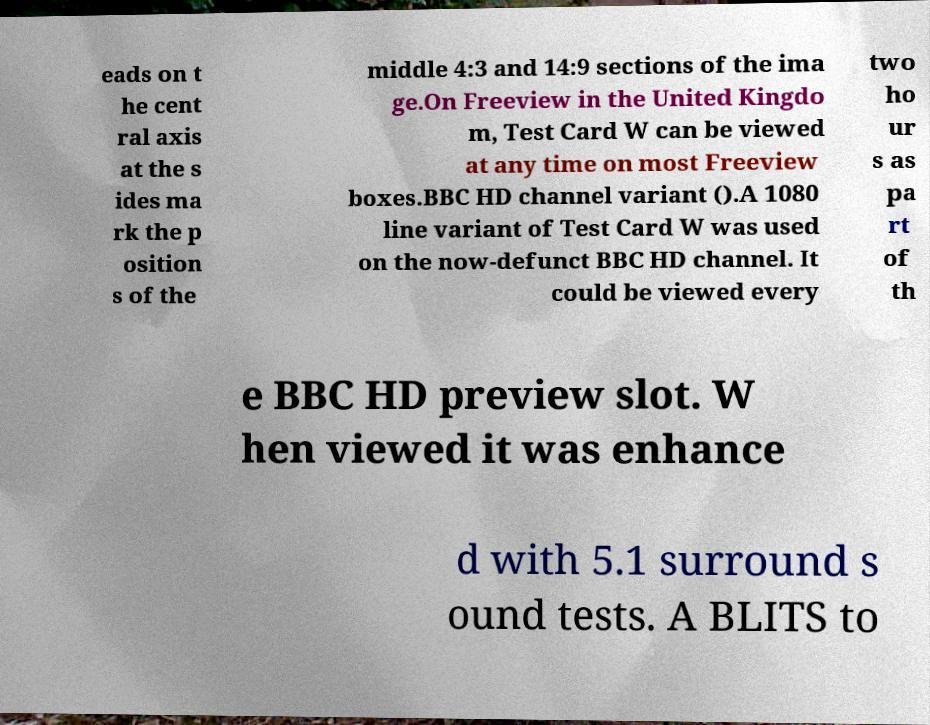Could you assist in decoding the text presented in this image and type it out clearly? eads on t he cent ral axis at the s ides ma rk the p osition s of the middle 4:3 and 14:9 sections of the ima ge.On Freeview in the United Kingdo m, Test Card W can be viewed at any time on most Freeview boxes.BBC HD channel variant ().A 1080 line variant of Test Card W was used on the now-defunct BBC HD channel. It could be viewed every two ho ur s as pa rt of th e BBC HD preview slot. W hen viewed it was enhance d with 5.1 surround s ound tests. A BLITS to 